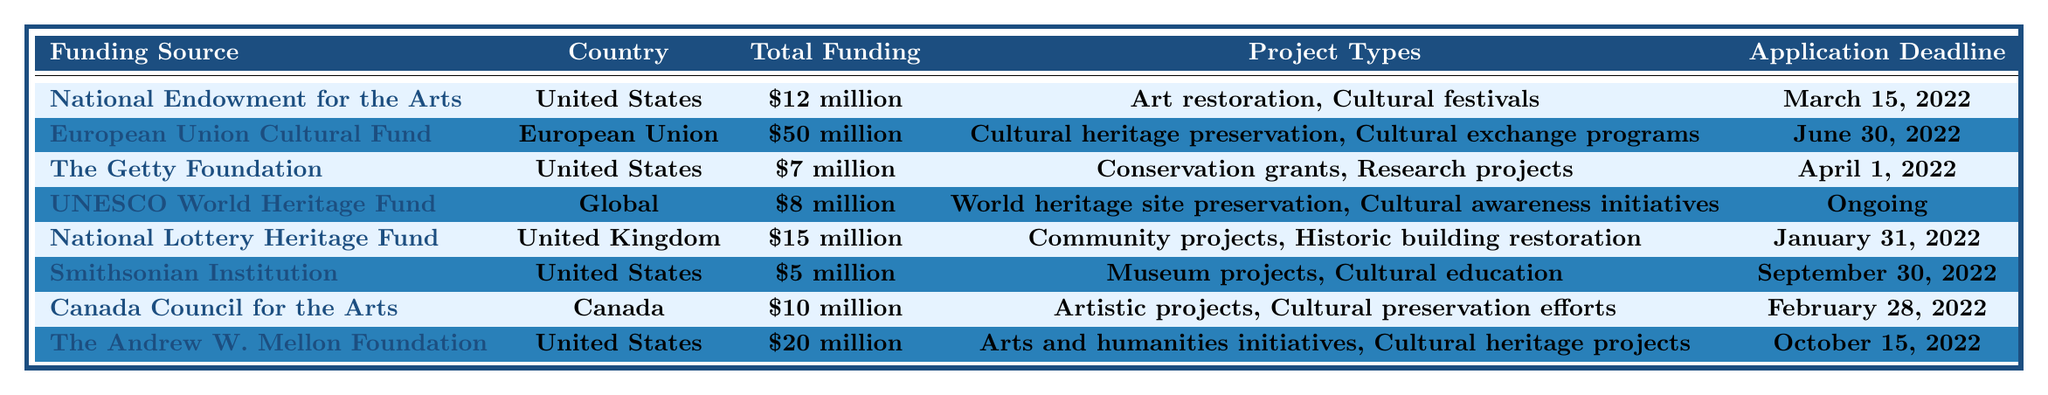What is the total funding offered by the European Union Cultural Fund? The table shows that the European Union Cultural Fund has a total funding of $50 million.
Answer: $50 million Which funding source has the earliest application deadline? The table lists the application deadlines, and the National Lottery Heritage Fund has the earliest deadline of January 31, 2022.
Answer: National Lottery Heritage Fund How much total funding is provided by all the sources from the United States? Adding the funding from the three sources from the United States: $12 million (National Endowment for the Arts) + $7 million (The Getty Foundation) + $5 million (Smithsonian Institution) + $20 million (The Andrew W. Mellon Foundation) = $44 million.
Answer: $44 million Is there a funding source with ongoing application deadlines? The table indicates that the UNESCO World Heritage Fund has an ongoing application deadline.
Answer: Yes Which funding source provides the smallest total funding? The table shows that the Smithsonian Institution has the smallest total funding amount, which is $5 million.
Answer: $5 million Calculate the average funding amount among the sources listed in the table. The total funding from all sources is $12 million + $50 million + $7 million + $8 million + $15 million + $5 million + $10 million + $20 million = $127 million. Dividing this by the 8 sources gives an average of $127 million / 8 = $15.875 million.
Answer: $15.875 million Are there any funding sources that support cultural festivals? The table indicates that the National Endowment for the Arts supports cultural festivals.
Answer: Yes Which country has the highest total funding for cultural preservation projects? According to the table, the European Union Cultural Fund has the highest total funding of $50 million.
Answer: European Union What is the combined total funding from the Canadian sources? The only Canadian source is the Canada Council for the Arts, which provides $10 million in funding. Thus, the combined total funding from Canadian sources is $10 million.
Answer: $10 million Are the projects of the Andrew W. Mellon Foundation focused only on cultural heritage? The table shows that the Andrew W. Mellon Foundation supports both arts and humanities initiatives and cultural heritage projects, indicating a broader focus.
Answer: No 